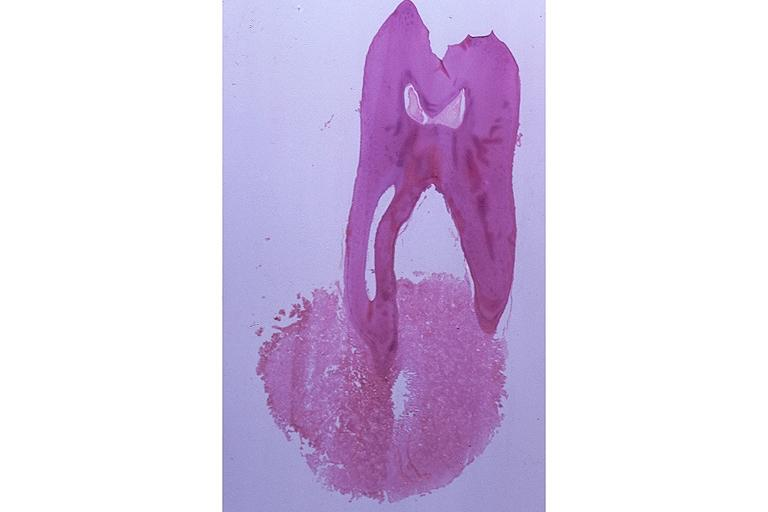s inflamed exocervix present?
Answer the question using a single word or phrase. No 